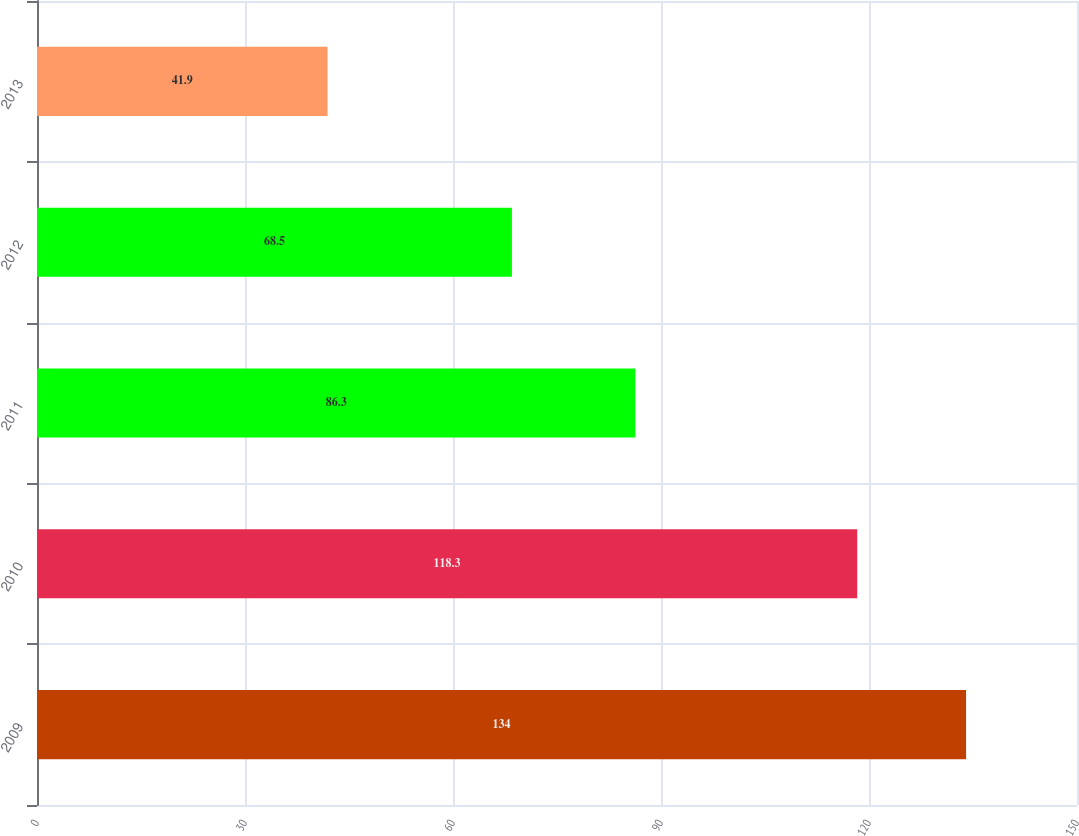Convert chart to OTSL. <chart><loc_0><loc_0><loc_500><loc_500><bar_chart><fcel>2009<fcel>2010<fcel>2011<fcel>2012<fcel>2013<nl><fcel>134<fcel>118.3<fcel>86.3<fcel>68.5<fcel>41.9<nl></chart> 